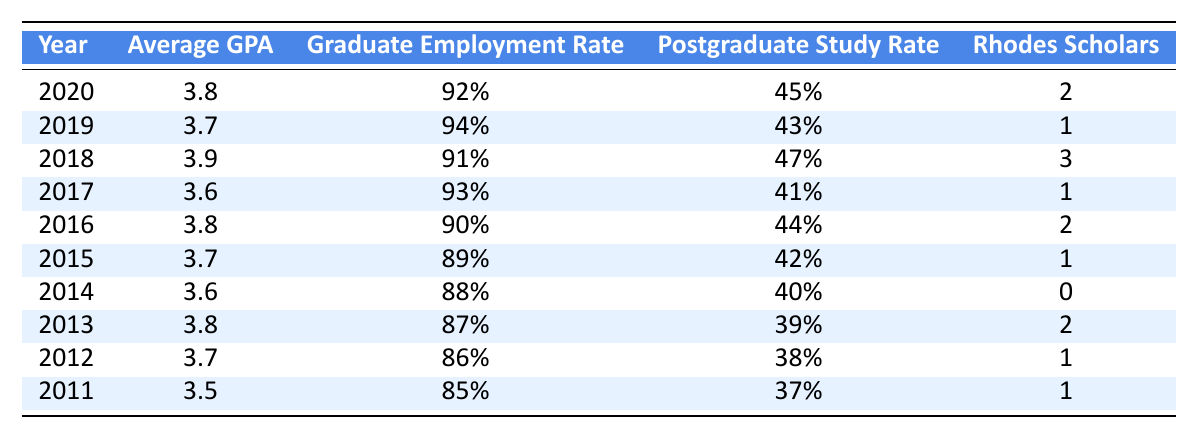What was the average GPA for graduates in 2020? The table indicates that the average GPA for graduates in 2020 is directly listed as 3.8.
Answer: 3.8 What percentage of graduates were employed in 2019? The graduate employment rate for 2019 is clearly shown in the table as 94%.
Answer: 94% How many Rhodes Scholars graduated in 2018? The table lists that 3 Rhodes Scholars graduated in the year 2018.
Answer: 3 What is the average Graduate Employment Rate from 2011 to 2015? To find the average, we sum the employment rates from these years: 85% + 86% + 87% + 89% + 90% = 437%. This sum divided by 5 years equals 87.4%.
Answer: 87.4% Did the Graduate Employment Rate increase from 2016 to 2020? The rates for these years are 90% (2016), 92% (2017), 93% (2018), and 94% (2019), showing a steady increase each year. Thus, the employment rate did increase.
Answer: Yes Which year had the highest Average GPA? By checking the GPA values, we find that 2018 had the highest average GPA of 3.9 among all listed years.
Answer: 2018 How many Rhodes Scholars were there in total from 2011 to 2020? The total number of Rhodes Scholars is found by adding the values: 1 + 1 + 2 + 0 + 1 + 2 + 3 + 1 + 2 = 13.
Answer: 13 Which year had the lowest Postgraduate Study Rate? Looking at the Postgraduate Study Rate column, the lowest rate is 37% in 2011.
Answer: 2011 Was the average GPA higher in 2019 compared to 2017? The average GPAs for 2019 and 2017 are 3.7 and 3.6, respectively. Since 3.7 > 3.6, it indicates that the average GPA was higher in 2019.
Answer: Yes In which year was the Graduate Employment Rate at its lowest? The lowest Graduate Employment Rate can be observed in 2014, which is listed as 88%.
Answer: 2014 